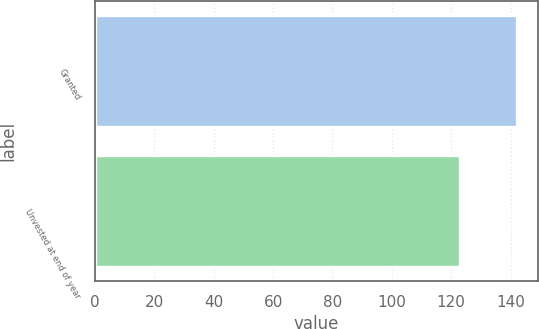Convert chart. <chart><loc_0><loc_0><loc_500><loc_500><bar_chart><fcel>Granted<fcel>Unvested at end of year<nl><fcel>142<fcel>123<nl></chart> 